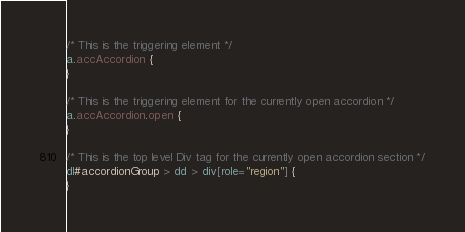Convert code to text. <code><loc_0><loc_0><loc_500><loc_500><_CSS_>
/* This is the triggering element */
a.accAccordion {
}

/* This is the triggering element for the currently open accordion */
a.accAccordion.open {
}

/* This is the top level Div tag for the currently open accordion section */
dl#accordionGroup > dd > div[role="region"] {
}
</code> 